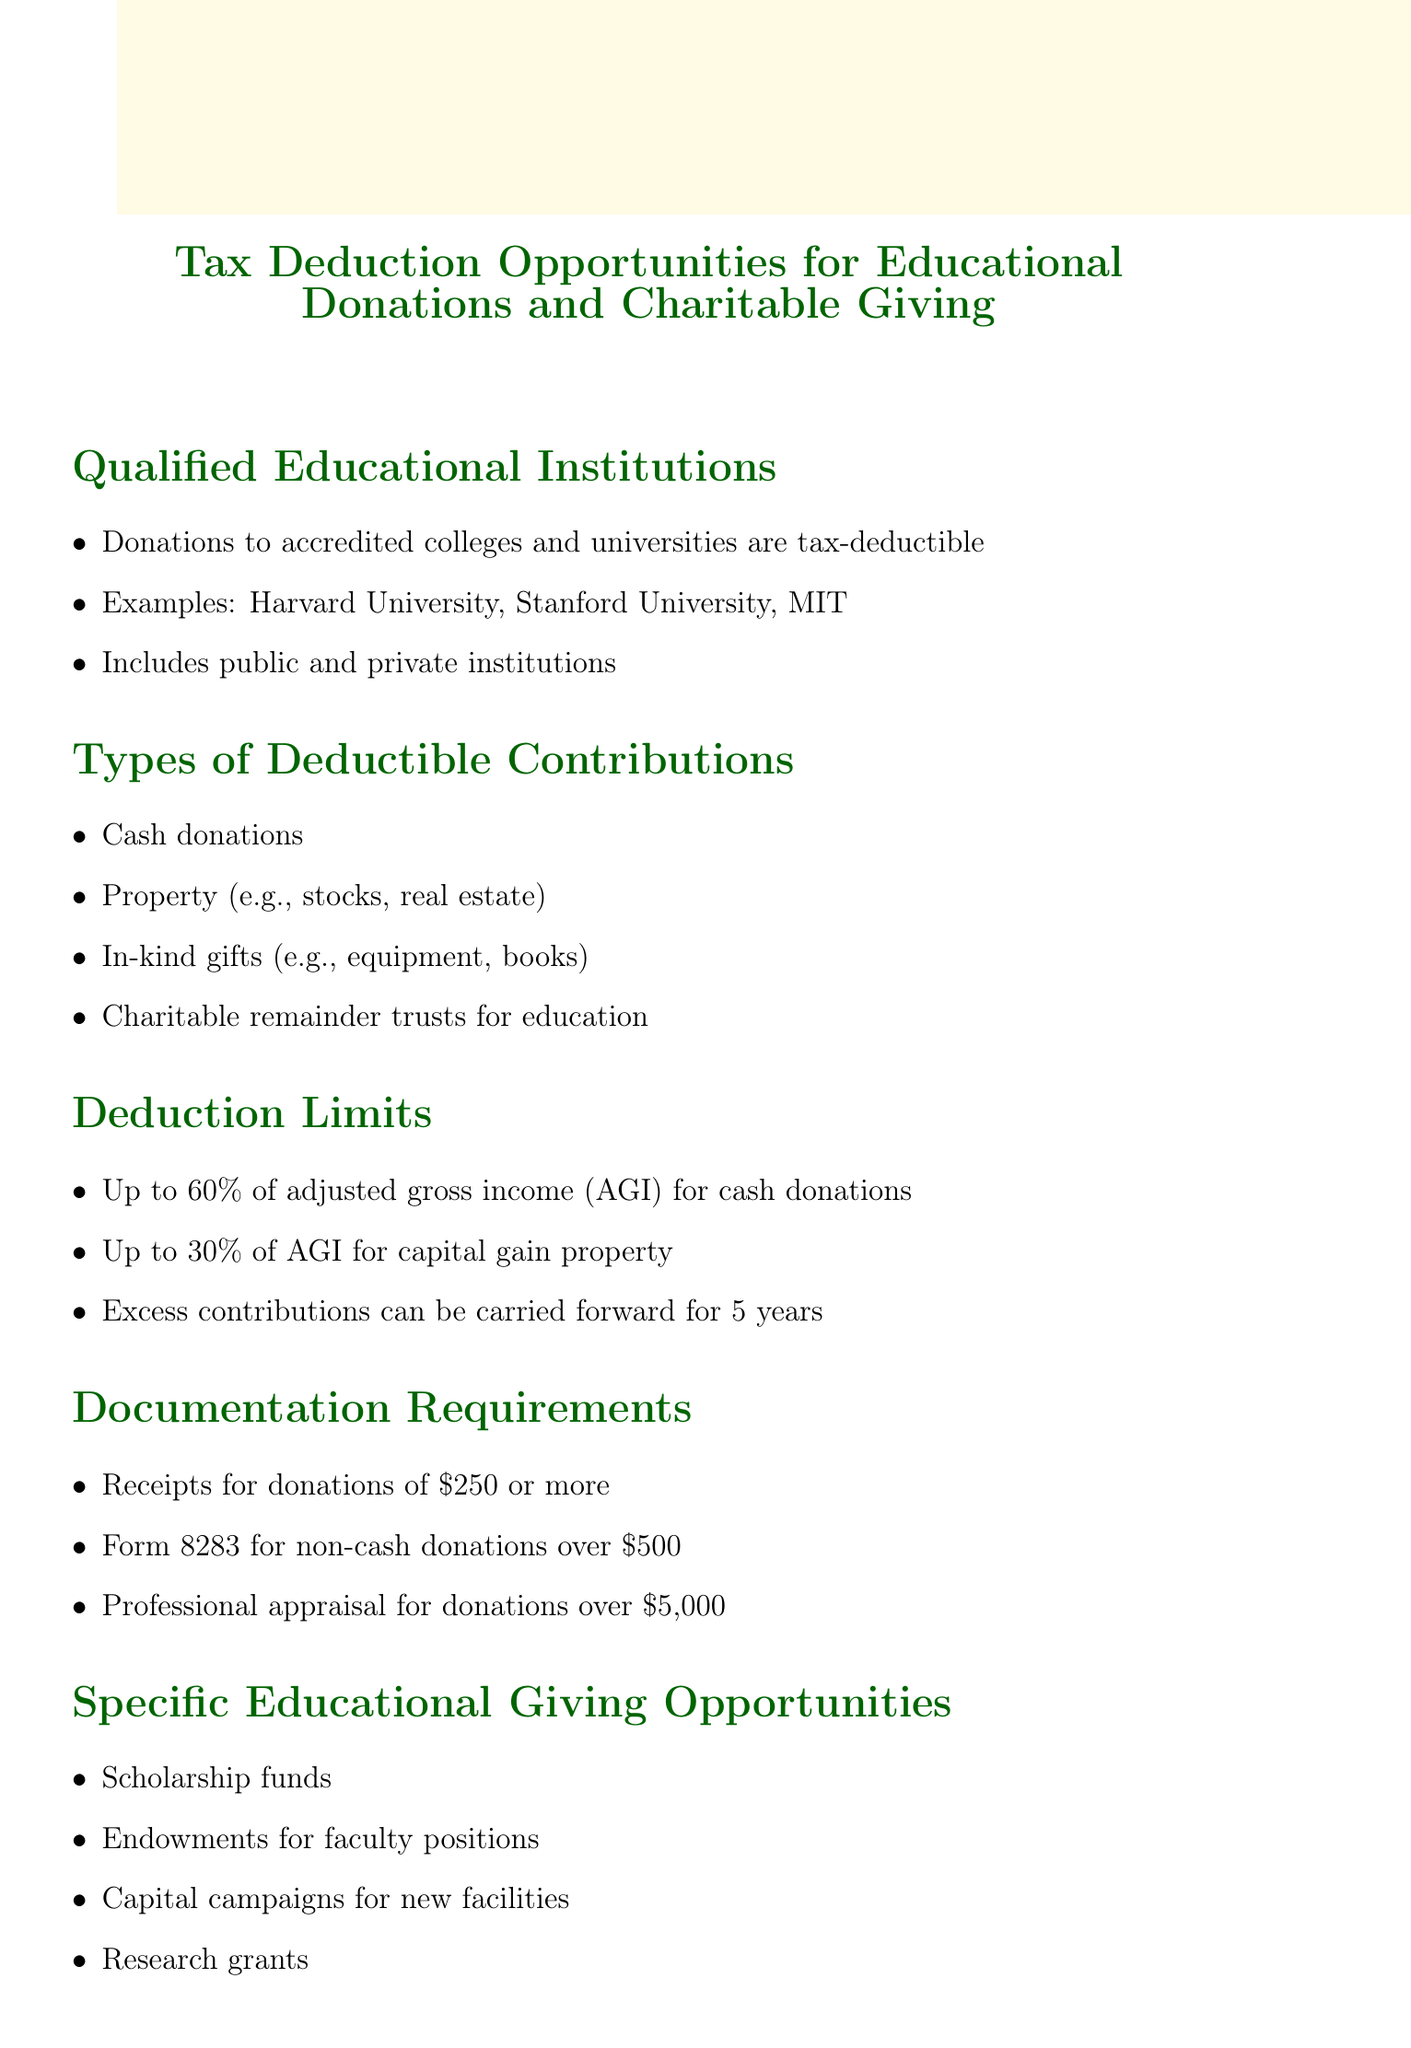What types of institutions can receive deductible donations? The document states that donations are tax-deductible to accredited colleges and universities, which include both public and private institutions.
Answer: Accredited colleges and universities What is the percentage limit for cash donations? According to the document, cash donations are limited to 60% of adjusted gross income (AGI).
Answer: 60% Which form is required for non-cash donations over $500? The document specifies that Form 8283 is required for non-cash donations that exceed $500.
Answer: Form 8283 What kind of funds are included in specific educational giving opportunities? The document lists scholarship funds as one of the specific educational giving opportunities available for donations.
Answer: Scholarship funds What tax benefit can alumni donors potentially receive? The document mentions that alumni donors may receive a potential reduction in taxable income as a tax benefit.
Answer: Reduction in taxable income What is the carrying forward period for excess contributions? The document states that excess contributions can be carried forward for five years.
Answer: 5 years What type of gifts counts as in-kind donations? The document specifies that in-kind gifts include items such as equipment and books.
Answer: Equipment, books What is the limit for capital gain property donations? According to the document, the limit for capital gain property donations is 30% of adjusted gross income (AGI).
Answer: 30% 